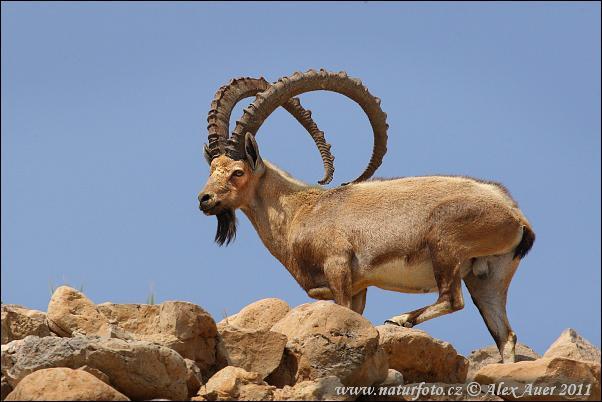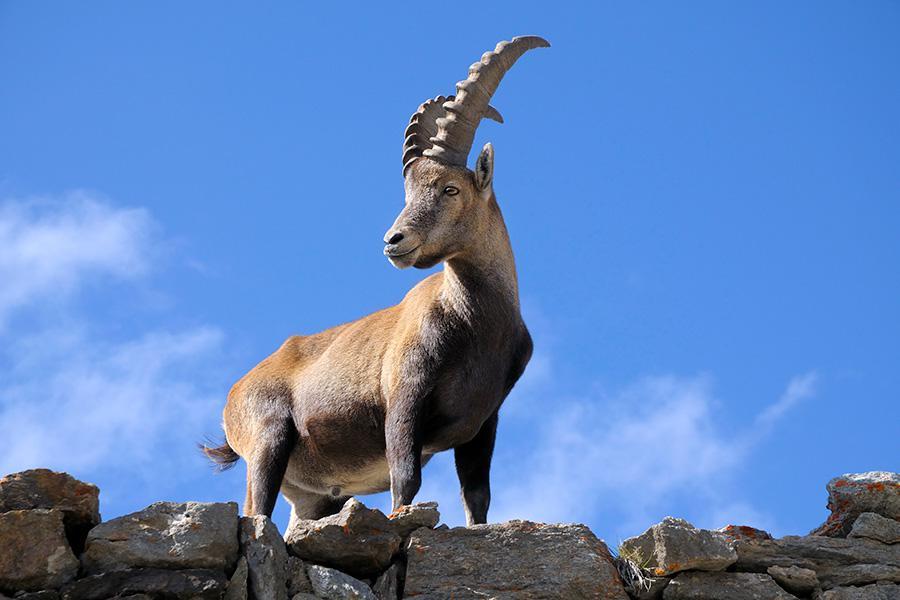The first image is the image on the left, the second image is the image on the right. Assess this claim about the two images: "Each image shows a long-horned animal standing on a rocky peak, and each animal is looking in the same general direction.". Correct or not? Answer yes or no. Yes. The first image is the image on the left, the second image is the image on the right. Considering the images on both sides, is "Both rams are standing on rocky ground." valid? Answer yes or no. Yes. 